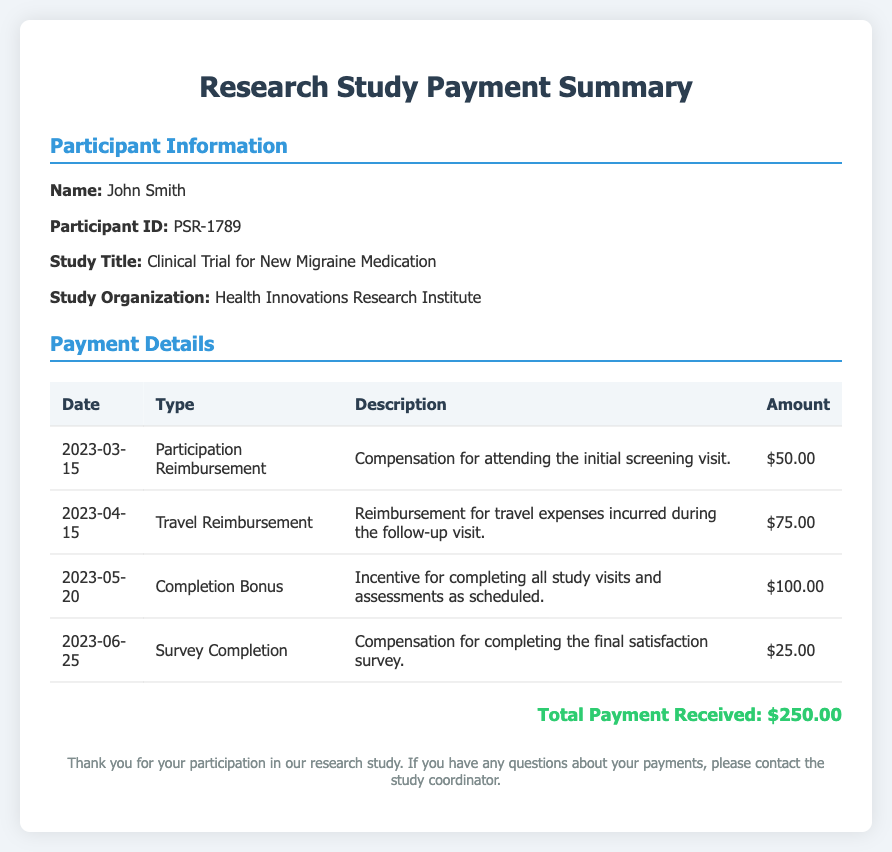What is the participant's name? The participant's name is provided in the document under participant information.
Answer: John Smith What was the total payment received? The total payment is calculated by summing all amounts listed in the payment details table.
Answer: $250.00 What type of reimbursement was received on April 15, 2023? The specific type of reimbursement for that date is detailed in the payment details section.
Answer: Travel Reimbursement Which study organization is conducting the research? The organization name is mentioned in the participant information section of the document.
Answer: Health Innovations Research Institute How much was the completion bonus? The completion bonus amount is specified in the payment details table.
Answer: $100.00 On what date was the survey completion compensation received? The date is listed in the payment details section associated with survey completion.
Answer: 2023-06-25 What was the reason for the reimbursement on March 15, 2023? The reason for the reimbursement is included in the description column of the payment details.
Answer: Compensation for attending the initial screening visit How many payments are listed in the payment details? The number of payments is determined by counting the rows in the payment details table.
Answer: 4 What incentive was offered for completing study visits? The incentive type is mentioned in the payment details section referring to the completion of study visits.
Answer: Completion Bonus 